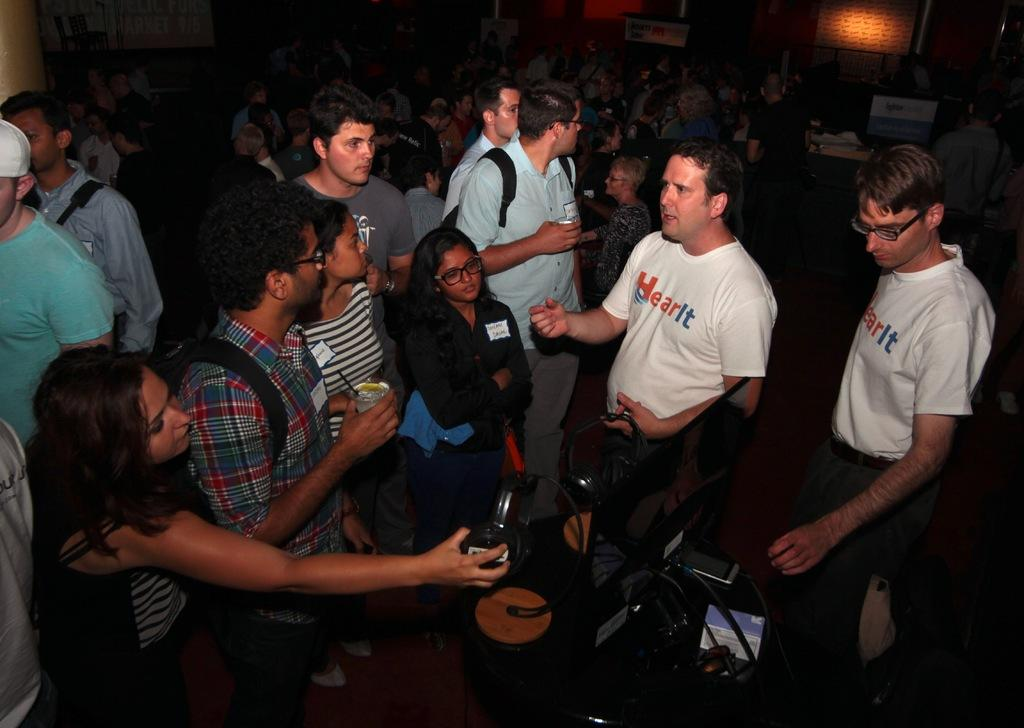What is the main subject of the image? The main subject of the image is a group of people. What are the people wearing in the image? The people are wearing headsets in the image. Can you describe the objects in the image? There are objects in the image, but their specific nature is not mentioned in the facts. What is the color of the background in the image? The background of the image is dark. What can be seen in the background of the image? Boards are visible in the background of the image. What type of acoustics can be heard in the image? The facts provided do not mention any sounds or acoustics in the image, so it is not possible to determine what type of acoustics can be heard. How does the scale of the objects in the image compare to the people? The facts provided do not give any information about the size or scale of the objects in the image, so it is not possible to compare them to the people. 